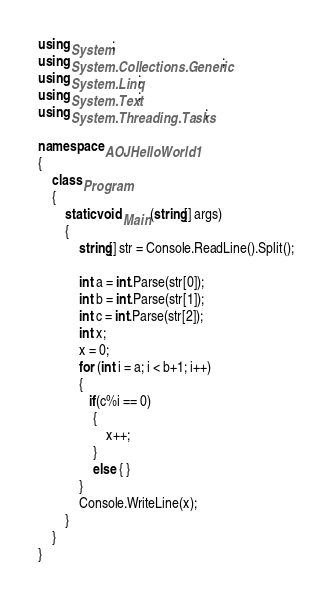<code> <loc_0><loc_0><loc_500><loc_500><_C#_>using System;
using System.Collections.Generic;
using System.Linq;
using System.Text;
using System.Threading.Tasks;

namespace AOJHelloWorld1
{
    class Program
    {
        static void Main(string[] args)
        {
            string[] str = Console.ReadLine().Split();

            int a = int.Parse(str[0]);
            int b = int.Parse(str[1]);
            int c = int.Parse(str[2]);
            int x;
            x = 0;
            for (int i = a; i < b+1; i++)
            {
               if(c%i == 0)
                {
                    x++;
                }
                else { }
            }
            Console.WriteLine(x);
        }
    }
}
</code> 